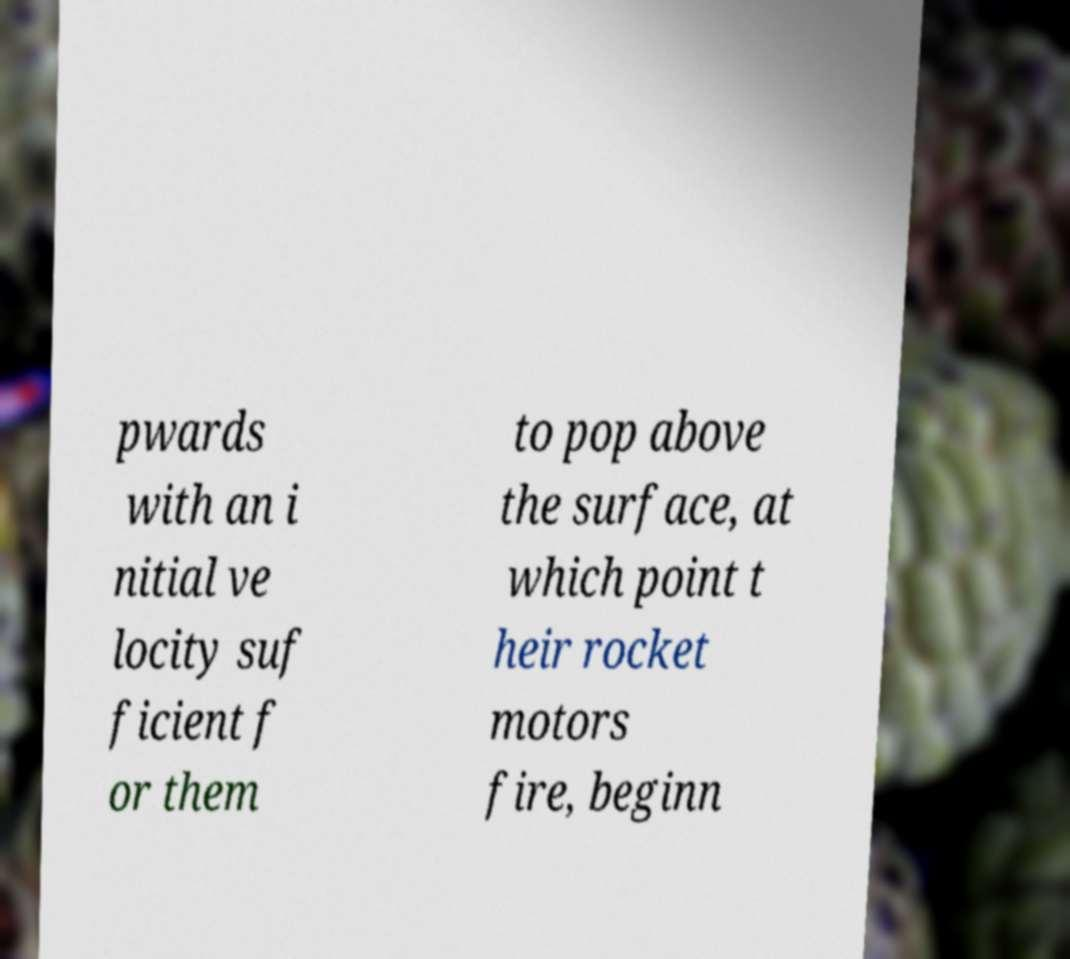I need the written content from this picture converted into text. Can you do that? pwards with an i nitial ve locity suf ficient f or them to pop above the surface, at which point t heir rocket motors fire, beginn 